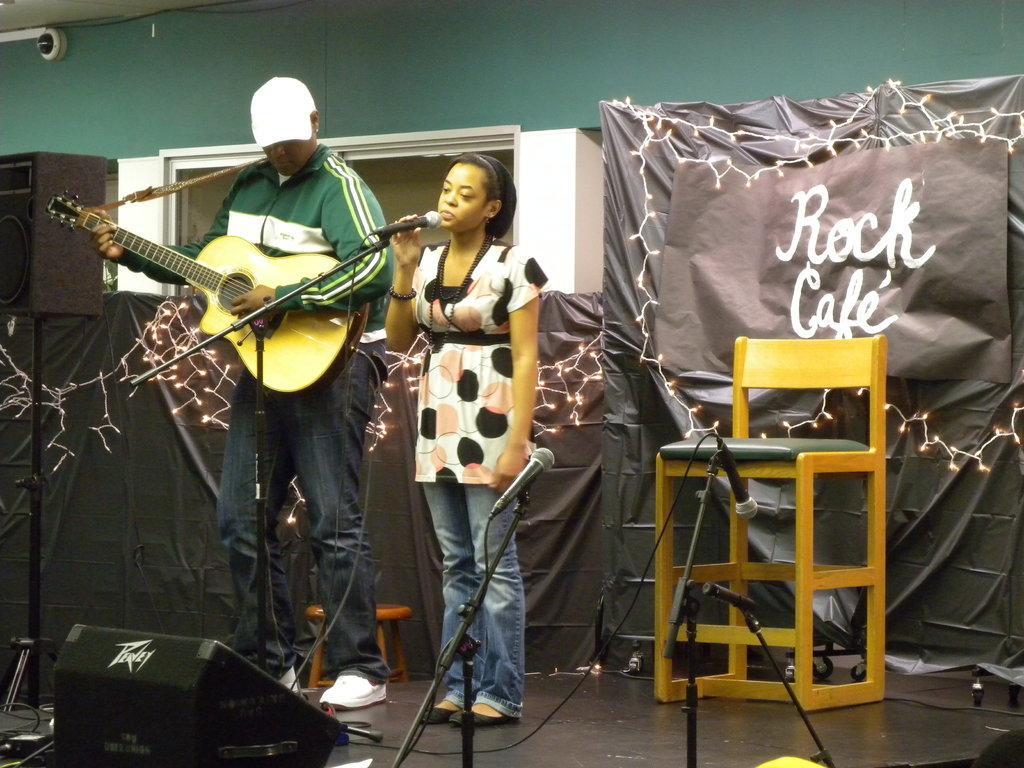In one or two sentences, can you explain what this image depicts? In this picture we can see man holding guitar in his hand and playing and beside to his woman singing on mic and and in background we can see speakers, wall, cloth, banner, chair. 